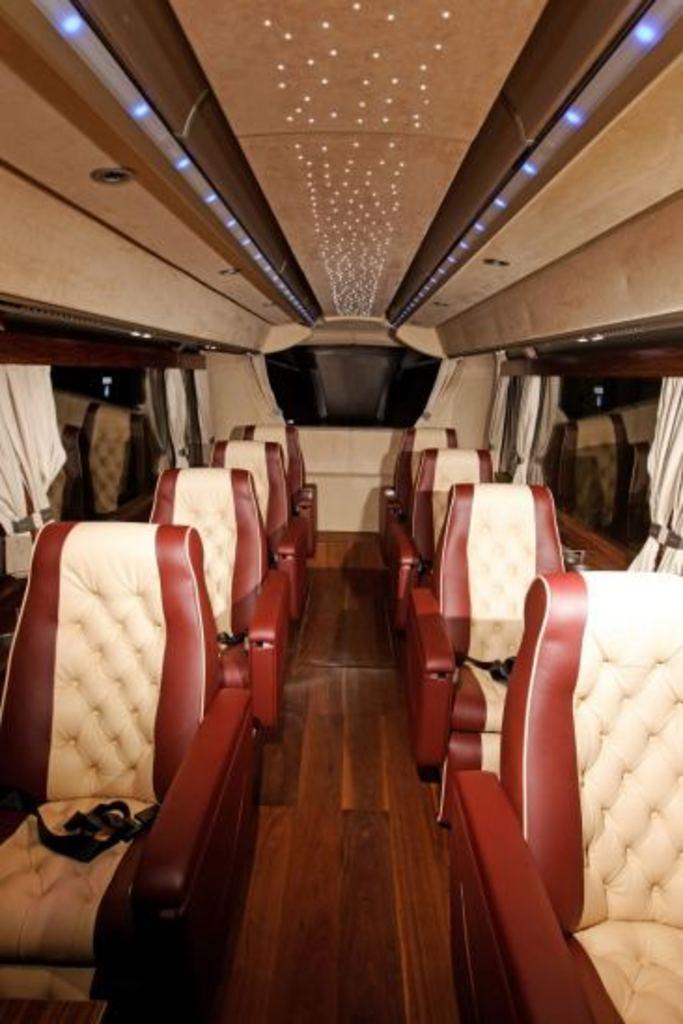Please provide a concise description of this image. This picture might be taken inside a bus. On the right side, we can see some seats and glass windows. In the background, we can see a display. At the top, we can see a roof with few lights. 